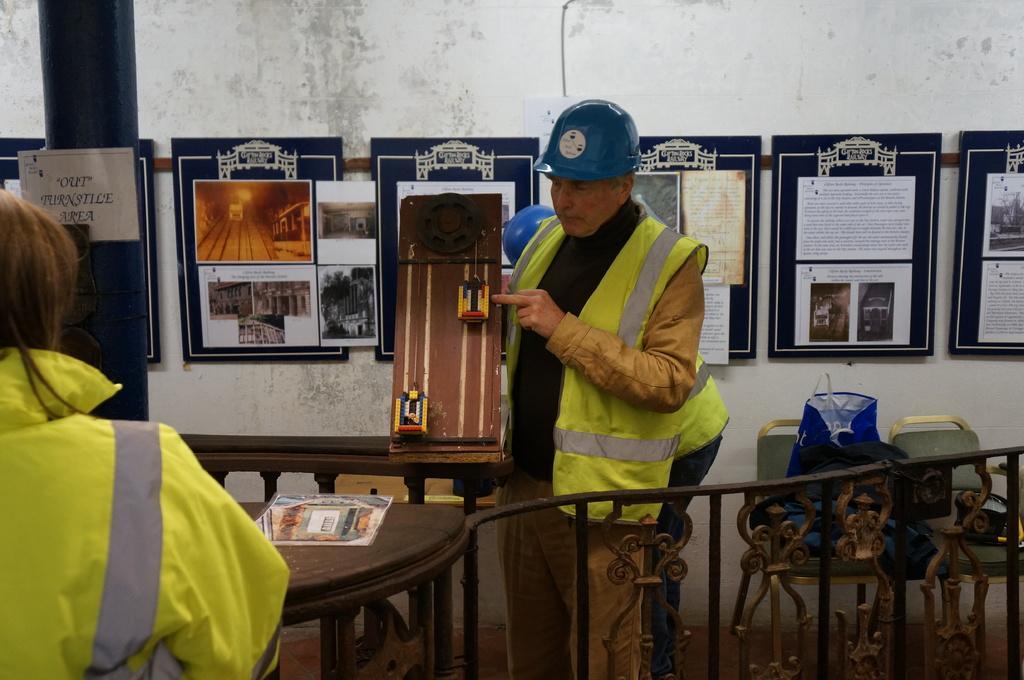In one or two sentences, can you explain what this image depicts? In this picture A man is standing here and holding a fabric some missionary like and one woman is sitting here there is a table back side there is a paper with frames there number of frames to the wall and there are two chairs 1 blue color cover if placed on the chair 